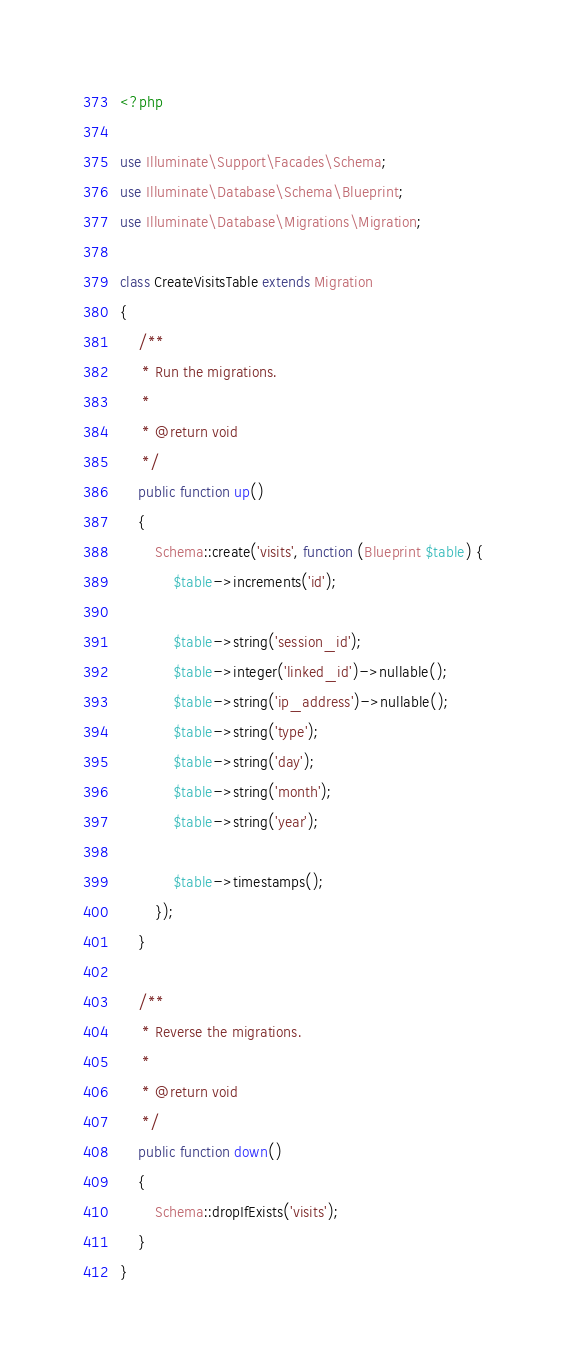<code> <loc_0><loc_0><loc_500><loc_500><_PHP_><?php

use Illuminate\Support\Facades\Schema;
use Illuminate\Database\Schema\Blueprint;
use Illuminate\Database\Migrations\Migration;

class CreateVisitsTable extends Migration
{
    /**
     * Run the migrations.
     *
     * @return void
     */
    public function up()
    {
        Schema::create('visits', function (Blueprint $table) {
            $table->increments('id');

            $table->string('session_id');
            $table->integer('linked_id')->nullable();
            $table->string('ip_address')->nullable();
            $table->string('type');
            $table->string('day');
            $table->string('month');
            $table->string('year');

            $table->timestamps();
        });
    }

    /**
     * Reverse the migrations.
     *
     * @return void
     */
    public function down()
    {
        Schema::dropIfExists('visits');
    }
}
</code> 